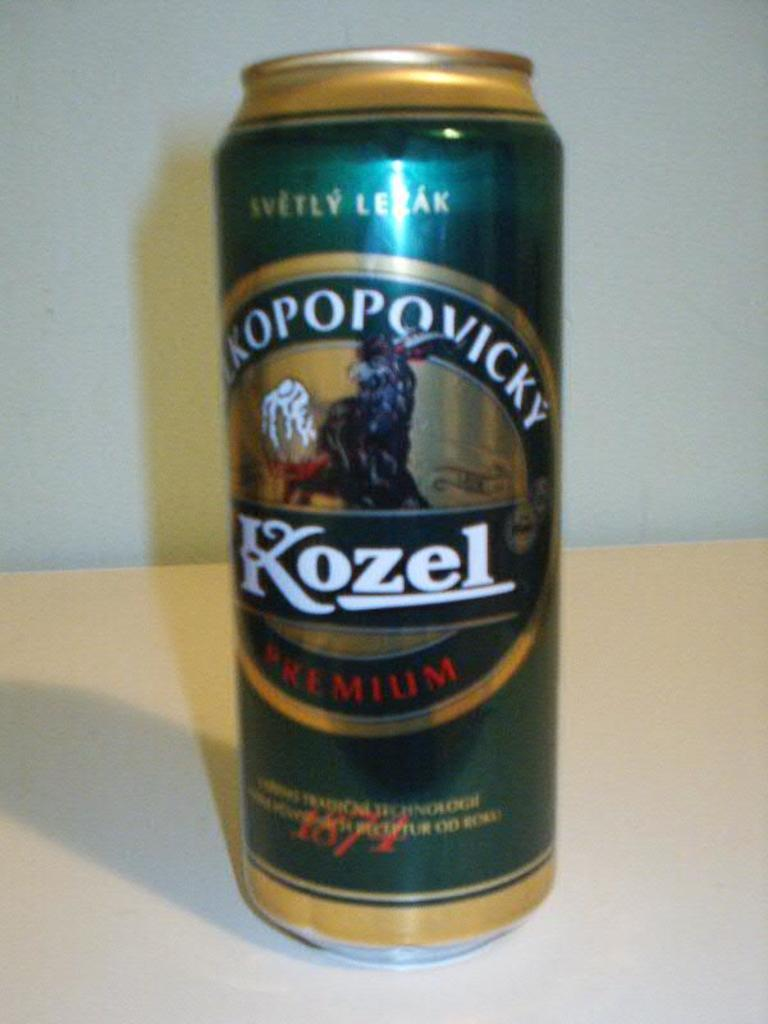<image>
Present a compact description of the photo's key features. A close up of a can of Kozel premium lager. 